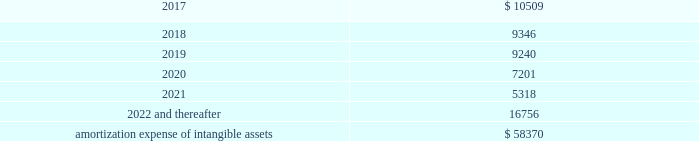Amortization expense , which is included in selling , general and administrative expenses , was $ 13.0 million , $ 13.9 million and $ 8.5 million for the years ended december 31 , 2016 , 2015 and 2014 , respectively .
The following is the estimated amortization expense for the company 2019s intangible assets as of december 31 , 2016 : ( in thousands ) .
At december 31 , 2016 , 2015 and 2014 , the company determined that its goodwill and indefinite- lived intangible assets were not impaired .
Credit facility and other long term debt credit facility the company is party to a credit agreement that provides revolving commitments for up to $ 1.25 billion of borrowings , as well as term loan commitments , in each case maturing in january 2021 .
As of december 31 , 2016 there was no outstanding balance under the revolving credit facility and $ 186.3 million of term loan borrowings remained outstanding .
At the company 2019s request and the lender 2019s consent , revolving and or term loan borrowings may be increased by up to $ 300.0 million in aggregate , subject to certain conditions as set forth in the credit agreement , as amended .
Incremental borrowings are uncommitted and the availability thereof , will depend on market conditions at the time the company seeks to incur such borrowings .
The borrowings under the revolving credit facility have maturities of less than one year .
Up to $ 50.0 million of the facility may be used for the issuance of letters of credit .
There were $ 2.6 million of letters of credit outstanding as of december 31 , 2016 .
The credit agreement contains negative covenants that , subject to significant exceptions , limit the ability of the company and its subsidiaries to , among other things , incur additional indebtedness , make restricted payments , pledge their assets as security , make investments , loans , advances , guarantees and acquisitions , undergo fundamental changes and enter into transactions with affiliates .
The company is also required to maintain a ratio of consolidated ebitda , as defined in the credit agreement , to consolidated interest expense of not less than 3.50 to 1.00 and is not permitted to allow the ratio of consolidated total indebtedness to consolidated ebitda to be greater than 3.25 to 1.00 ( 201cconsolidated leverage ratio 201d ) .
As of december 31 , 2016 , the company was in compliance with these ratios .
In addition , the credit agreement contains events of default that are customary for a facility of this nature , and includes a cross default provision whereby an event of default under other material indebtedness , as defined in the credit agreement , will be considered an event of default under the credit agreement .
Borrowings under the credit agreement bear interest at a rate per annum equal to , at the company 2019s option , either ( a ) an alternate base rate , or ( b ) a rate based on the rates applicable for deposits in the interbank market for u.s .
Dollars or the applicable currency in which the loans are made ( 201cadjusted libor 201d ) , plus in each case an applicable margin .
The applicable margin for loans will .
What was the difference in millions of amortization expense between 2014 and 2015? 
Computations: (13.9 - 8.5)
Answer: 5.4. 